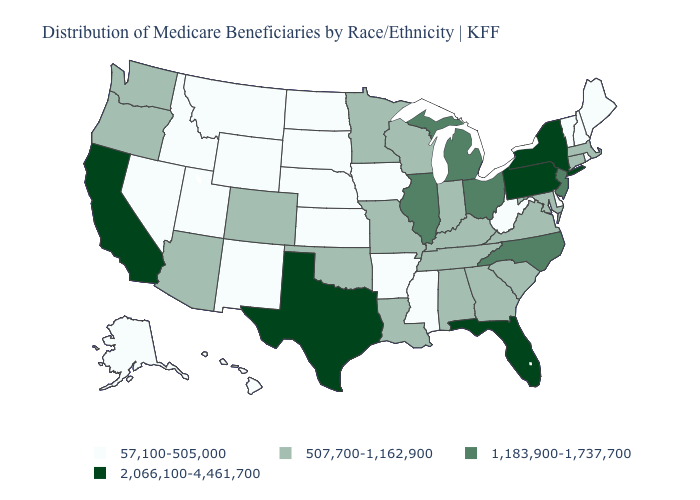Does the map have missing data?
Answer briefly. No. Which states have the highest value in the USA?
Be succinct. California, Florida, New York, Pennsylvania, Texas. Name the states that have a value in the range 2,066,100-4,461,700?
Write a very short answer. California, Florida, New York, Pennsylvania, Texas. Name the states that have a value in the range 507,700-1,162,900?
Concise answer only. Alabama, Arizona, Colorado, Connecticut, Georgia, Indiana, Kentucky, Louisiana, Maryland, Massachusetts, Minnesota, Missouri, Oklahoma, Oregon, South Carolina, Tennessee, Virginia, Washington, Wisconsin. What is the lowest value in the West?
Give a very brief answer. 57,100-505,000. Does the map have missing data?
Answer briefly. No. Does Texas have the same value as California?
Short answer required. Yes. Name the states that have a value in the range 1,183,900-1,737,700?
Quick response, please. Illinois, Michigan, New Jersey, North Carolina, Ohio. Does Pennsylvania have the highest value in the USA?
Be succinct. Yes. Name the states that have a value in the range 507,700-1,162,900?
Be succinct. Alabama, Arizona, Colorado, Connecticut, Georgia, Indiana, Kentucky, Louisiana, Maryland, Massachusetts, Minnesota, Missouri, Oklahoma, Oregon, South Carolina, Tennessee, Virginia, Washington, Wisconsin. Is the legend a continuous bar?
Quick response, please. No. Does Illinois have a higher value than Michigan?
Short answer required. No. Name the states that have a value in the range 1,183,900-1,737,700?
Give a very brief answer. Illinois, Michigan, New Jersey, North Carolina, Ohio. Does Utah have the highest value in the USA?
Answer briefly. No. What is the value of Washington?
Short answer required. 507,700-1,162,900. 